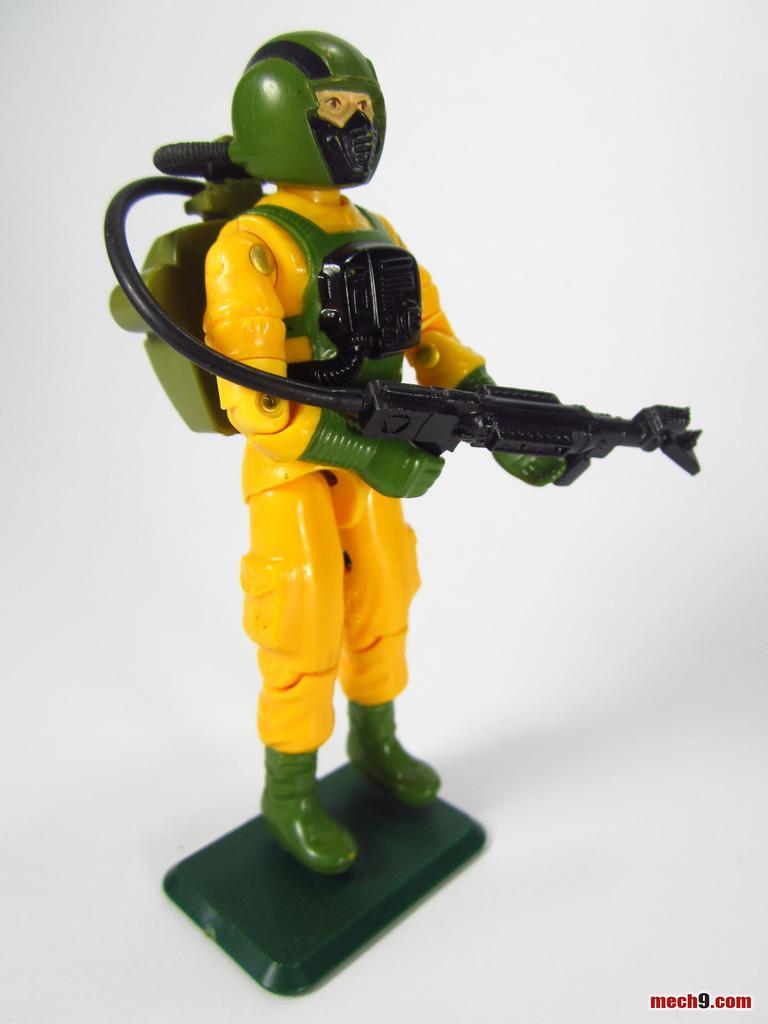How would you summarize this image in a sentence or two? The picture consists of a yellow color toy with green helmet. To the toy there is a gun like object. The background is white. 